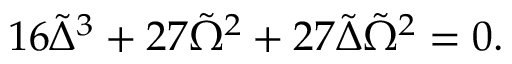Convert formula to latex. <formula><loc_0><loc_0><loc_500><loc_500>1 6 \tilde { \Delta } ^ { 3 } + 2 7 \tilde { \Omega } ^ { 2 } + 2 7 \tilde { \Delta } \tilde { \Omega } ^ { 2 } = 0 .</formula> 